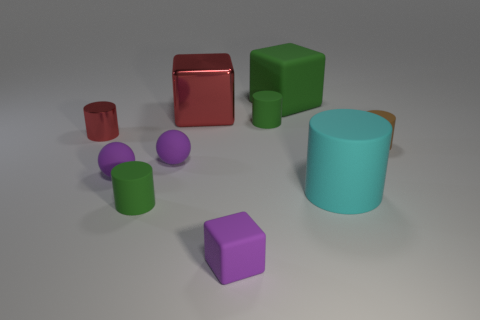There is a green cylinder left of the metal block; is its size the same as the cyan object?
Ensure brevity in your answer.  No. Is the number of small green cylinders to the right of the large green thing greater than the number of tiny rubber balls that are to the left of the small matte block?
Your answer should be compact. No. The cylinder that is in front of the cyan cylinder in front of the tiny matte thing to the right of the big cyan thing is what color?
Your answer should be very brief. Green. Does the cylinder that is in front of the large cylinder have the same color as the large matte cube?
Provide a succinct answer. Yes. What number of other things are the same color as the tiny metallic object?
Provide a short and direct response. 1. How many objects are either tiny purple matte cubes or tiny cyan matte cylinders?
Offer a terse response. 1. What number of things are small yellow matte objects or green rubber cylinders behind the red cylinder?
Offer a very short reply. 1. Are the green block and the large red cube made of the same material?
Your answer should be very brief. No. What number of other objects are there of the same material as the large cyan cylinder?
Provide a short and direct response. 7. Are there more brown objects than big blue rubber objects?
Offer a very short reply. Yes. 